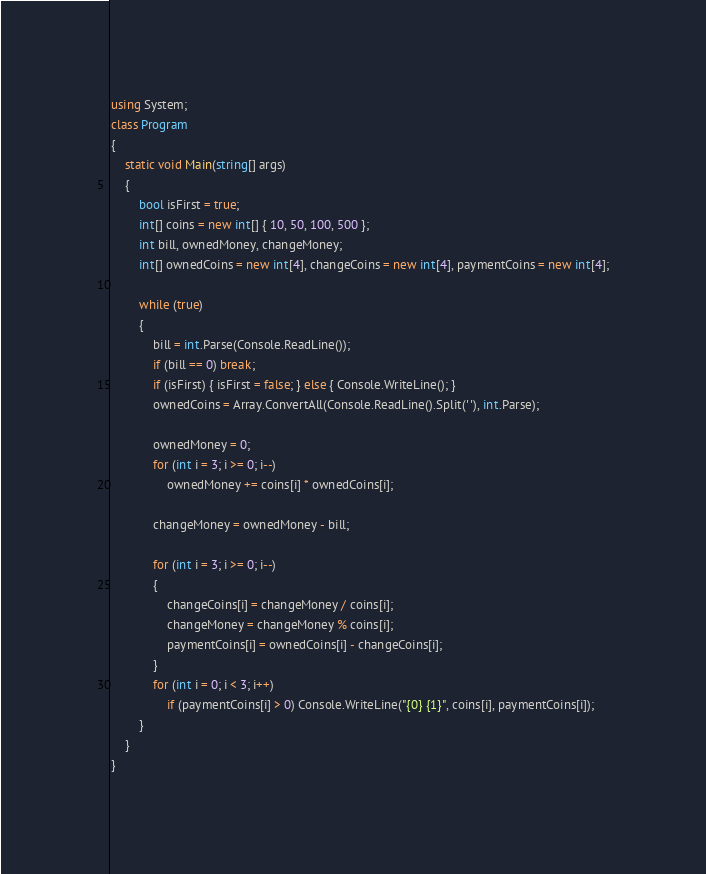<code> <loc_0><loc_0><loc_500><loc_500><_C#_>using System;
class Program
{
    static void Main(string[] args)
    {
        bool isFirst = true;
        int[] coins = new int[] { 10, 50, 100, 500 };
        int bill, ownedMoney, changeMoney;
        int[] ownedCoins = new int[4], changeCoins = new int[4], paymentCoins = new int[4];

        while (true)
        {
            bill = int.Parse(Console.ReadLine());
            if (bill == 0) break;
            if (isFirst) { isFirst = false; } else { Console.WriteLine(); }
            ownedCoins = Array.ConvertAll(Console.ReadLine().Split(' '), int.Parse);

            ownedMoney = 0;
            for (int i = 3; i >= 0; i--)
                ownedMoney += coins[i] * ownedCoins[i];

            changeMoney = ownedMoney - bill;

            for (int i = 3; i >= 0; i--)
            {
                changeCoins[i] = changeMoney / coins[i];
                changeMoney = changeMoney % coins[i];
                paymentCoins[i] = ownedCoins[i] - changeCoins[i];
            }
            for (int i = 0; i < 3; i++)
                if (paymentCoins[i] > 0) Console.WriteLine("{0} {1}", coins[i], paymentCoins[i]);
        }
    }
}
</code> 